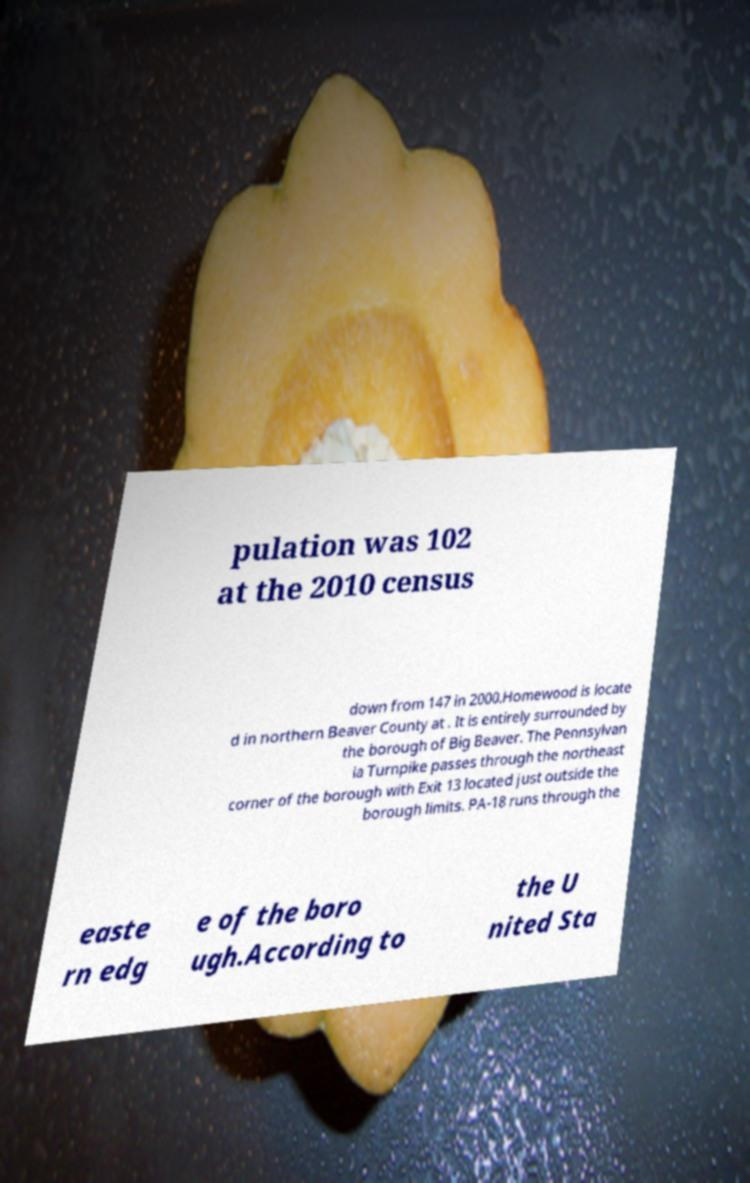There's text embedded in this image that I need extracted. Can you transcribe it verbatim? pulation was 102 at the 2010 census down from 147 in 2000.Homewood is locate d in northern Beaver County at . It is entirely surrounded by the borough of Big Beaver. The Pennsylvan ia Turnpike passes through the northeast corner of the borough with Exit 13 located just outside the borough limits. PA-18 runs through the easte rn edg e of the boro ugh.According to the U nited Sta 